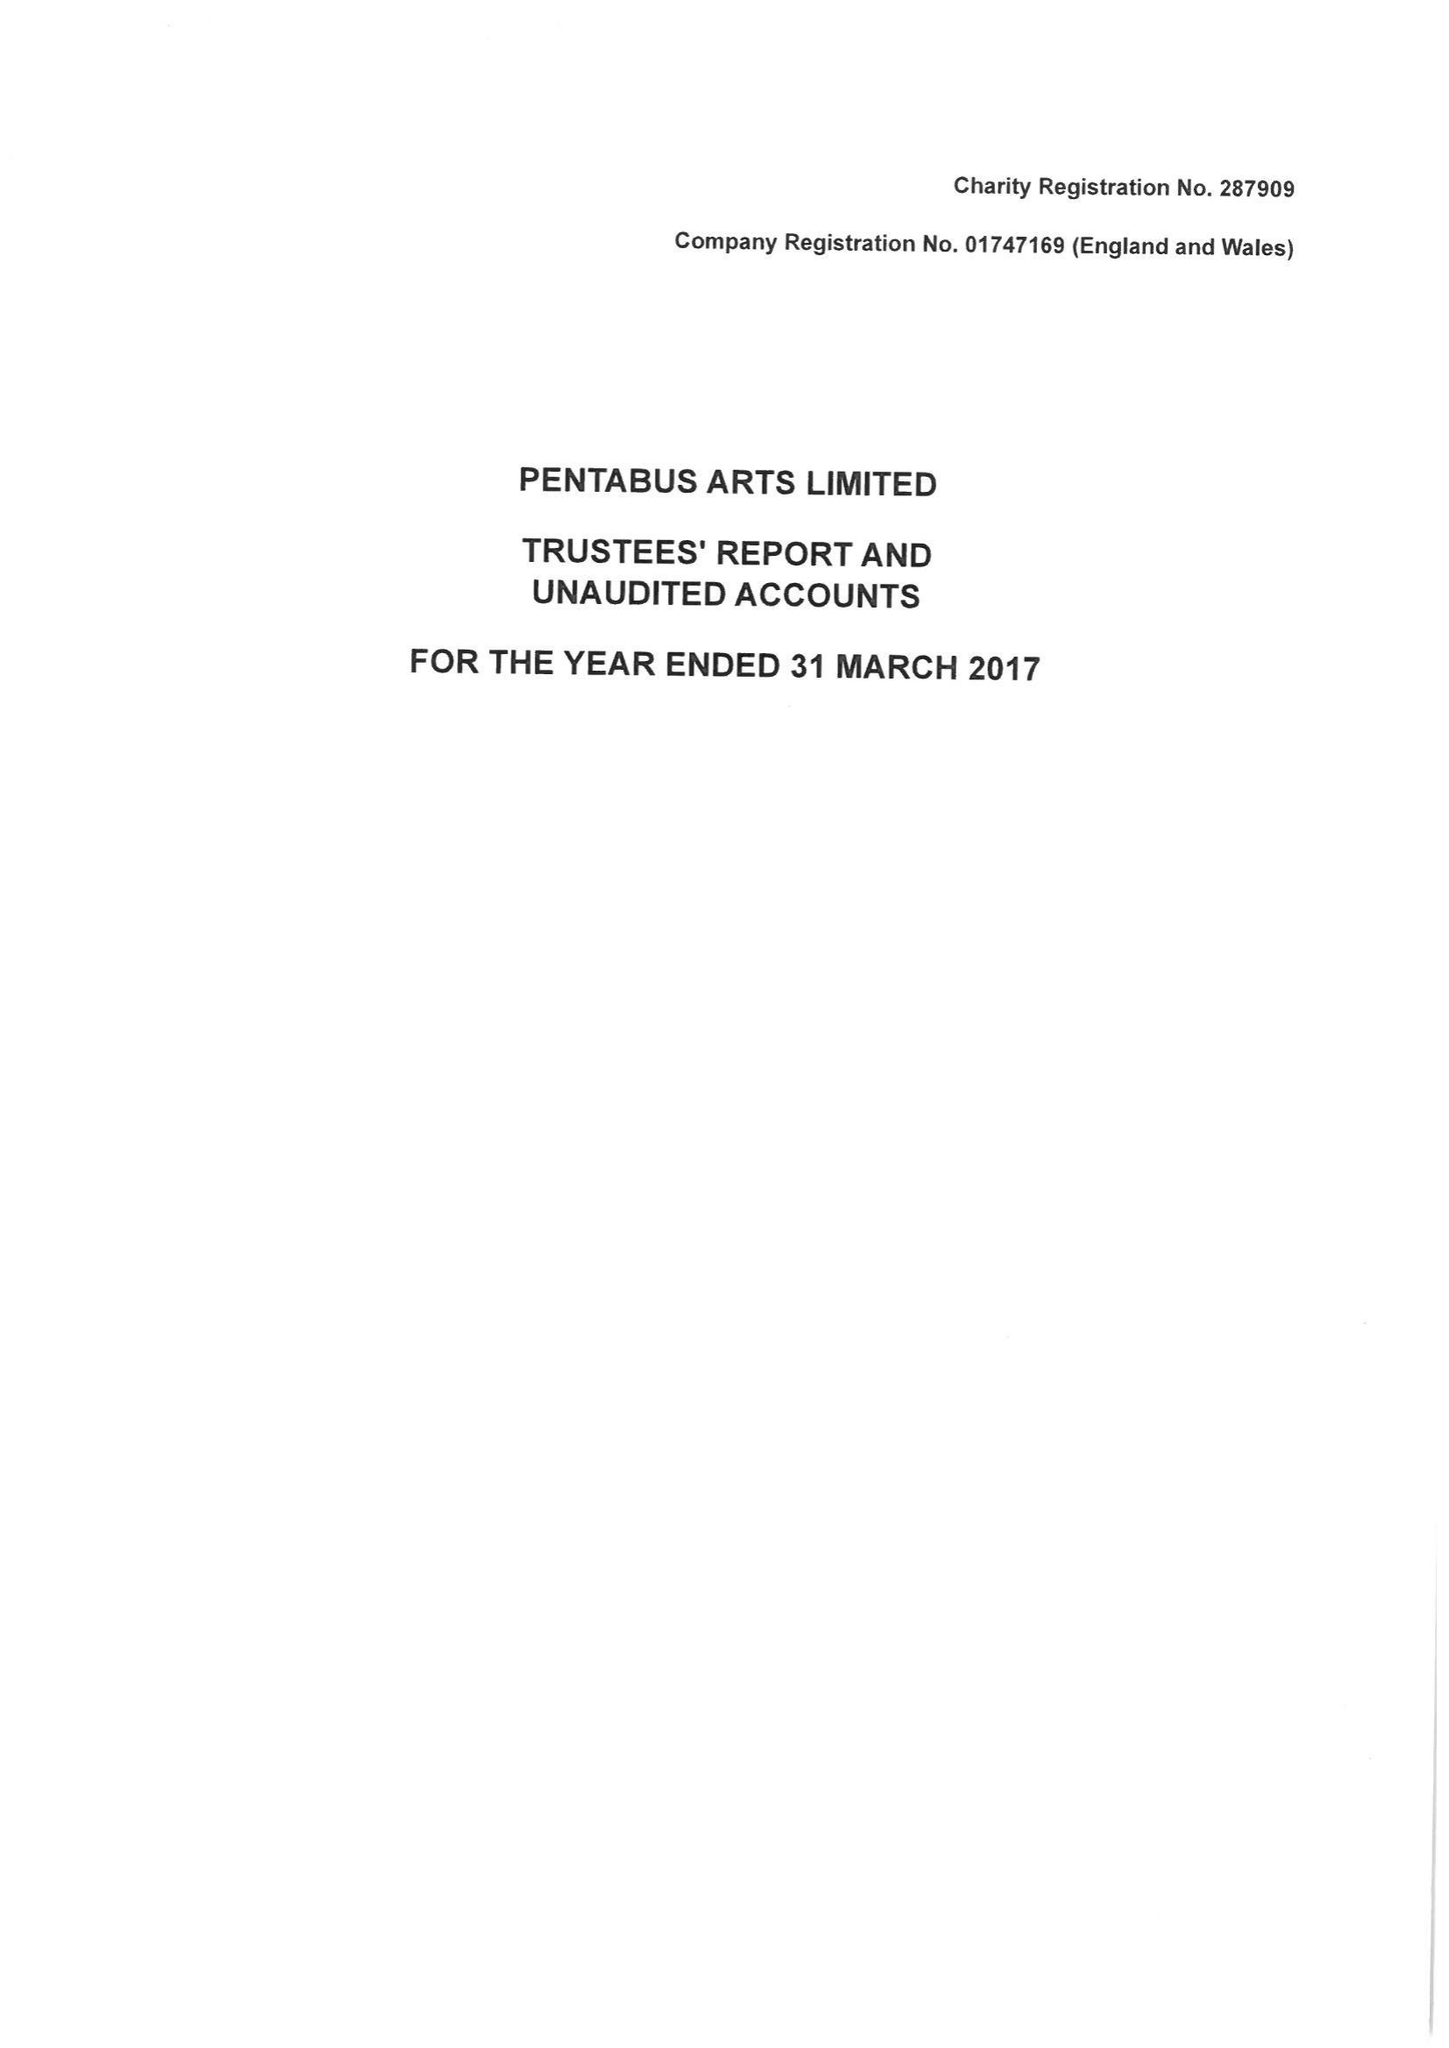What is the value for the income_annually_in_british_pounds?
Answer the question using a single word or phrase. 374706.00 